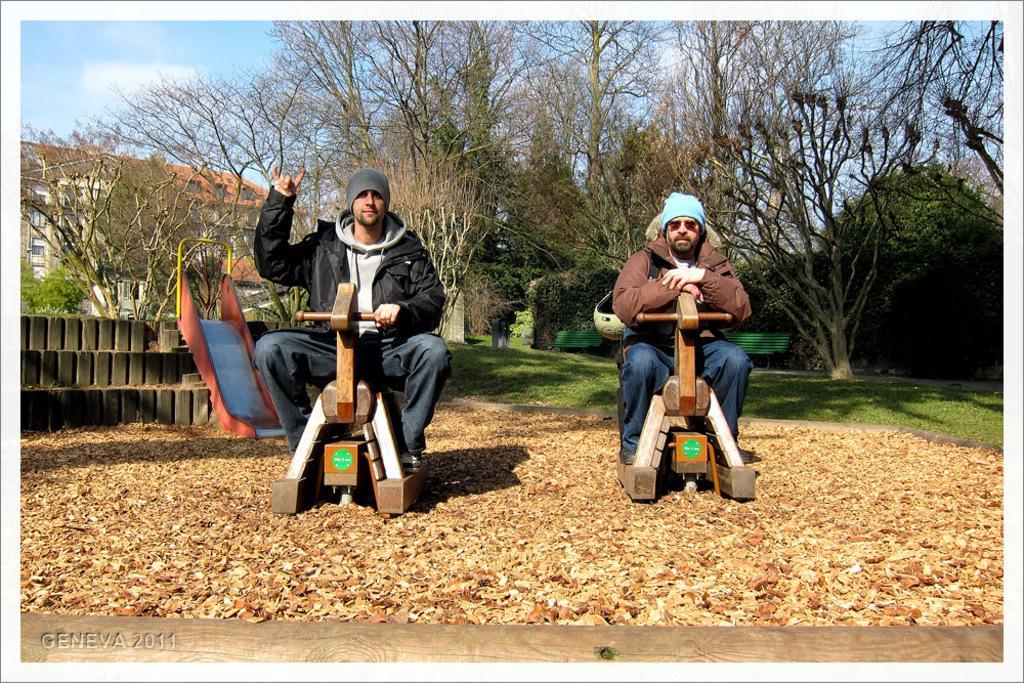Can you describe this image briefly? In the foreground of the picture there are dry leaves, wooden objects, people, wooden pole and other objects. In the middle of the picture there are trees, slide, buildings and other objects. In the background at the top there is sky. 